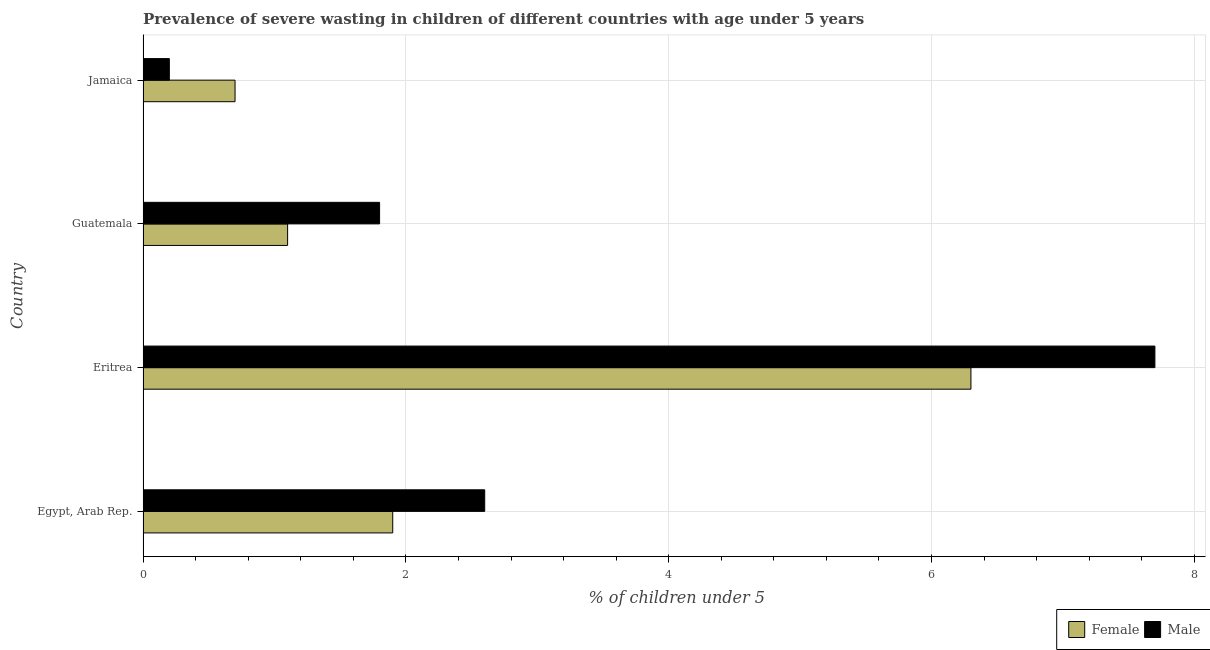How many bars are there on the 1st tick from the top?
Keep it short and to the point. 2. How many bars are there on the 2nd tick from the bottom?
Make the answer very short. 2. What is the label of the 2nd group of bars from the top?
Provide a succinct answer. Guatemala. What is the percentage of undernourished male children in Egypt, Arab Rep.?
Your answer should be compact. 2.6. Across all countries, what is the maximum percentage of undernourished female children?
Give a very brief answer. 6.3. Across all countries, what is the minimum percentage of undernourished male children?
Offer a very short reply. 0.2. In which country was the percentage of undernourished female children maximum?
Offer a very short reply. Eritrea. In which country was the percentage of undernourished male children minimum?
Provide a short and direct response. Jamaica. What is the total percentage of undernourished female children in the graph?
Your response must be concise. 10. What is the difference between the percentage of undernourished female children in Egypt, Arab Rep. and the percentage of undernourished male children in Jamaica?
Give a very brief answer. 1.7. What is the average percentage of undernourished male children per country?
Keep it short and to the point. 3.08. In how many countries, is the percentage of undernourished male children greater than 2 %?
Your answer should be compact. 2. Is the difference between the percentage of undernourished female children in Guatemala and Jamaica greater than the difference between the percentage of undernourished male children in Guatemala and Jamaica?
Offer a terse response. No. What is the difference between the highest and the lowest percentage of undernourished female children?
Provide a short and direct response. 5.6. In how many countries, is the percentage of undernourished male children greater than the average percentage of undernourished male children taken over all countries?
Your response must be concise. 1. Is the sum of the percentage of undernourished female children in Egypt, Arab Rep. and Eritrea greater than the maximum percentage of undernourished male children across all countries?
Offer a terse response. Yes. What does the 1st bar from the bottom in Jamaica represents?
Provide a short and direct response. Female. How many countries are there in the graph?
Ensure brevity in your answer.  4. Are the values on the major ticks of X-axis written in scientific E-notation?
Make the answer very short. No. Where does the legend appear in the graph?
Provide a succinct answer. Bottom right. What is the title of the graph?
Provide a short and direct response. Prevalence of severe wasting in children of different countries with age under 5 years. What is the label or title of the X-axis?
Make the answer very short.  % of children under 5. What is the label or title of the Y-axis?
Offer a very short reply. Country. What is the  % of children under 5 of Female in Egypt, Arab Rep.?
Give a very brief answer. 1.9. What is the  % of children under 5 in Male in Egypt, Arab Rep.?
Your answer should be very brief. 2.6. What is the  % of children under 5 of Female in Eritrea?
Your answer should be compact. 6.3. What is the  % of children under 5 of Male in Eritrea?
Provide a succinct answer. 7.7. What is the  % of children under 5 in Female in Guatemala?
Ensure brevity in your answer.  1.1. What is the  % of children under 5 in Male in Guatemala?
Ensure brevity in your answer.  1.8. What is the  % of children under 5 of Female in Jamaica?
Your answer should be very brief. 0.7. What is the  % of children under 5 in Male in Jamaica?
Ensure brevity in your answer.  0.2. Across all countries, what is the maximum  % of children under 5 of Female?
Offer a terse response. 6.3. Across all countries, what is the maximum  % of children under 5 in Male?
Your response must be concise. 7.7. Across all countries, what is the minimum  % of children under 5 in Female?
Offer a very short reply. 0.7. Across all countries, what is the minimum  % of children under 5 of Male?
Offer a very short reply. 0.2. What is the difference between the  % of children under 5 of Male in Egypt, Arab Rep. and that in Guatemala?
Ensure brevity in your answer.  0.8. What is the difference between the  % of children under 5 in Female in Egypt, Arab Rep. and that in Jamaica?
Give a very brief answer. 1.2. What is the difference between the  % of children under 5 of Male in Egypt, Arab Rep. and that in Jamaica?
Make the answer very short. 2.4. What is the difference between the  % of children under 5 of Female in Eritrea and that in Guatemala?
Provide a succinct answer. 5.2. What is the difference between the  % of children under 5 in Female in Eritrea and that in Jamaica?
Offer a very short reply. 5.6. What is the difference between the  % of children under 5 of Male in Eritrea and that in Jamaica?
Keep it short and to the point. 7.5. What is the difference between the  % of children under 5 in Female in Guatemala and that in Jamaica?
Your response must be concise. 0.4. What is the difference between the  % of children under 5 of Female in Egypt, Arab Rep. and the  % of children under 5 of Male in Jamaica?
Your answer should be very brief. 1.7. What is the difference between the  % of children under 5 in Female in Eritrea and the  % of children under 5 in Male in Jamaica?
Offer a very short reply. 6.1. What is the average  % of children under 5 in Male per country?
Your response must be concise. 3.08. What is the difference between the  % of children under 5 in Female and  % of children under 5 in Male in Egypt, Arab Rep.?
Your answer should be very brief. -0.7. What is the ratio of the  % of children under 5 of Female in Egypt, Arab Rep. to that in Eritrea?
Provide a short and direct response. 0.3. What is the ratio of the  % of children under 5 in Male in Egypt, Arab Rep. to that in Eritrea?
Offer a terse response. 0.34. What is the ratio of the  % of children under 5 of Female in Egypt, Arab Rep. to that in Guatemala?
Provide a short and direct response. 1.73. What is the ratio of the  % of children under 5 of Male in Egypt, Arab Rep. to that in Guatemala?
Keep it short and to the point. 1.44. What is the ratio of the  % of children under 5 in Female in Egypt, Arab Rep. to that in Jamaica?
Give a very brief answer. 2.71. What is the ratio of the  % of children under 5 in Female in Eritrea to that in Guatemala?
Your answer should be very brief. 5.73. What is the ratio of the  % of children under 5 in Male in Eritrea to that in Guatemala?
Provide a short and direct response. 4.28. What is the ratio of the  % of children under 5 in Male in Eritrea to that in Jamaica?
Offer a terse response. 38.5. What is the ratio of the  % of children under 5 in Female in Guatemala to that in Jamaica?
Your answer should be compact. 1.57. What is the ratio of the  % of children under 5 of Male in Guatemala to that in Jamaica?
Your response must be concise. 9. What is the difference between the highest and the lowest  % of children under 5 in Female?
Your response must be concise. 5.6. What is the difference between the highest and the lowest  % of children under 5 of Male?
Give a very brief answer. 7.5. 